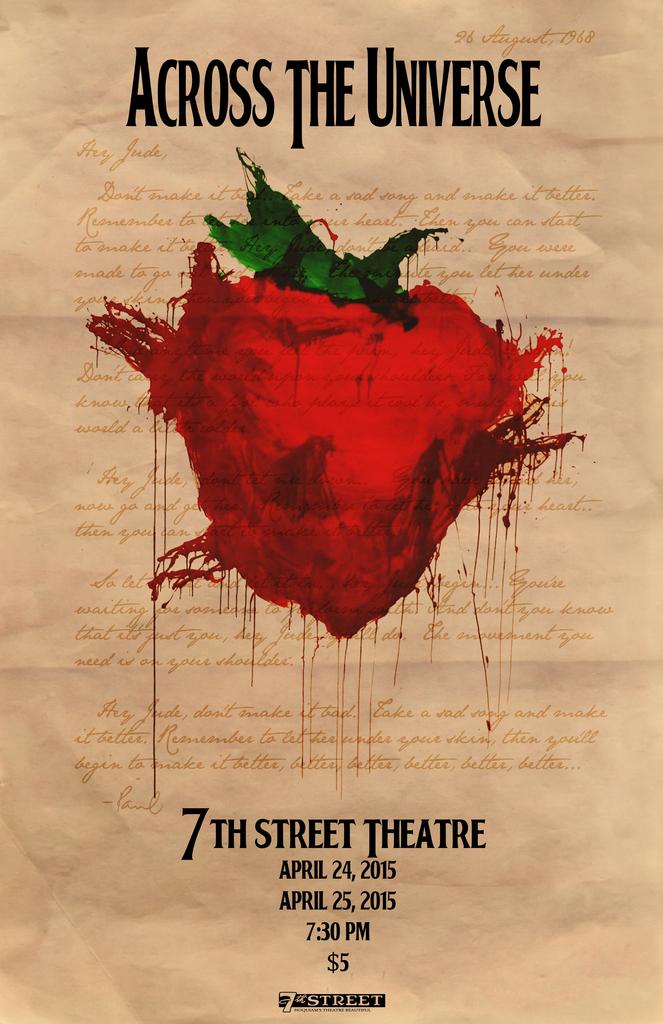What time is the show?
Your response must be concise. 7:30 pm. What is the name of the theatre?
Offer a terse response. 7th street theatre. 